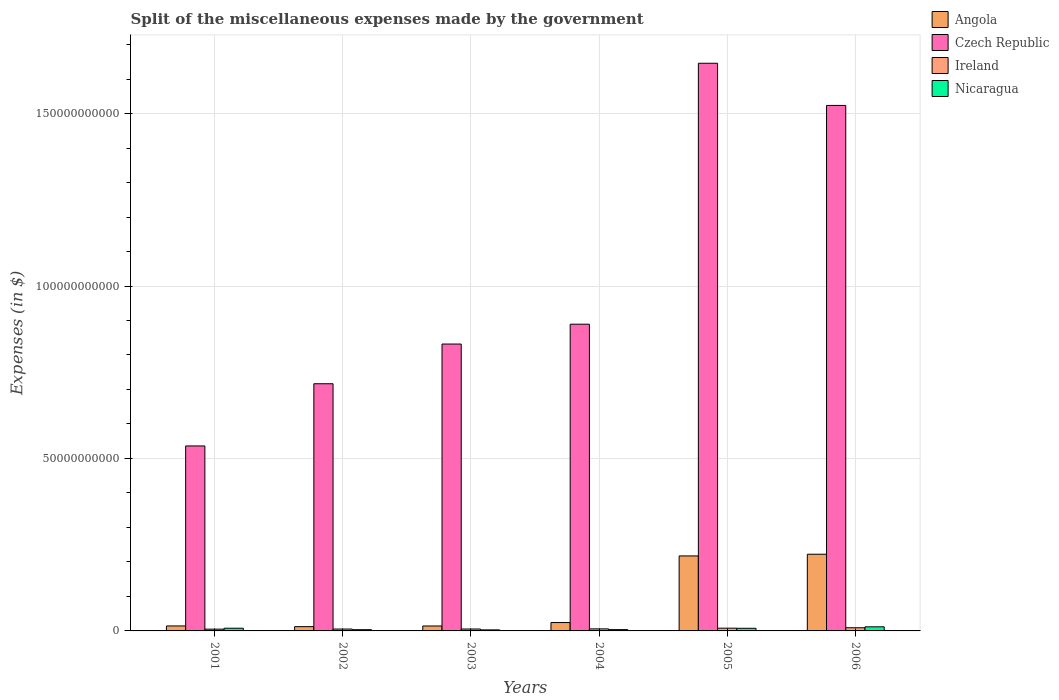How many different coloured bars are there?
Your response must be concise. 4. How many bars are there on the 3rd tick from the left?
Give a very brief answer. 4. What is the label of the 1st group of bars from the left?
Provide a short and direct response. 2001. In how many cases, is the number of bars for a given year not equal to the number of legend labels?
Give a very brief answer. 0. What is the miscellaneous expenses made by the government in Nicaragua in 2003?
Provide a short and direct response. 3.00e+08. Across all years, what is the maximum miscellaneous expenses made by the government in Angola?
Your answer should be very brief. 2.22e+1. Across all years, what is the minimum miscellaneous expenses made by the government in Ireland?
Offer a terse response. 5.16e+08. In which year was the miscellaneous expenses made by the government in Angola minimum?
Ensure brevity in your answer.  2002. What is the total miscellaneous expenses made by the government in Angola in the graph?
Provide a short and direct response. 5.05e+1. What is the difference between the miscellaneous expenses made by the government in Angola in 2003 and that in 2006?
Provide a succinct answer. -2.08e+1. What is the difference between the miscellaneous expenses made by the government in Ireland in 2005 and the miscellaneous expenses made by the government in Angola in 2004?
Your answer should be very brief. -1.63e+09. What is the average miscellaneous expenses made by the government in Angola per year?
Make the answer very short. 8.42e+09. In the year 2006, what is the difference between the miscellaneous expenses made by the government in Angola and miscellaneous expenses made by the government in Czech Republic?
Ensure brevity in your answer.  -1.30e+11. In how many years, is the miscellaneous expenses made by the government in Ireland greater than 90000000000 $?
Provide a succinct answer. 0. What is the ratio of the miscellaneous expenses made by the government in Czech Republic in 2002 to that in 2003?
Provide a succinct answer. 0.86. Is the miscellaneous expenses made by the government in Nicaragua in 2001 less than that in 2003?
Make the answer very short. No. Is the difference between the miscellaneous expenses made by the government in Angola in 2001 and 2003 greater than the difference between the miscellaneous expenses made by the government in Czech Republic in 2001 and 2003?
Your answer should be compact. Yes. What is the difference between the highest and the second highest miscellaneous expenses made by the government in Angola?
Offer a terse response. 4.93e+08. What is the difference between the highest and the lowest miscellaneous expenses made by the government in Ireland?
Your response must be concise. 4.00e+08. Is the sum of the miscellaneous expenses made by the government in Ireland in 2002 and 2004 greater than the maximum miscellaneous expenses made by the government in Nicaragua across all years?
Your answer should be very brief. No. What does the 3rd bar from the left in 2006 represents?
Provide a short and direct response. Ireland. What does the 3rd bar from the right in 2005 represents?
Make the answer very short. Czech Republic. Is it the case that in every year, the sum of the miscellaneous expenses made by the government in Nicaragua and miscellaneous expenses made by the government in Czech Republic is greater than the miscellaneous expenses made by the government in Ireland?
Provide a succinct answer. Yes. How many bars are there?
Give a very brief answer. 24. Does the graph contain any zero values?
Your answer should be very brief. No. Does the graph contain grids?
Your answer should be compact. Yes. What is the title of the graph?
Your answer should be very brief. Split of the miscellaneous expenses made by the government. What is the label or title of the Y-axis?
Your answer should be compact. Expenses (in $). What is the Expenses (in $) of Angola in 2001?
Give a very brief answer. 1.44e+09. What is the Expenses (in $) in Czech Republic in 2001?
Your answer should be very brief. 5.36e+1. What is the Expenses (in $) of Ireland in 2001?
Keep it short and to the point. 5.16e+08. What is the Expenses (in $) of Nicaragua in 2001?
Offer a terse response. 7.80e+08. What is the Expenses (in $) of Angola in 2002?
Ensure brevity in your answer.  1.24e+09. What is the Expenses (in $) of Czech Republic in 2002?
Provide a short and direct response. 7.17e+1. What is the Expenses (in $) in Ireland in 2002?
Provide a succinct answer. 5.45e+08. What is the Expenses (in $) of Nicaragua in 2002?
Offer a very short reply. 3.61e+08. What is the Expenses (in $) of Angola in 2003?
Offer a very short reply. 1.43e+09. What is the Expenses (in $) in Czech Republic in 2003?
Provide a short and direct response. 8.32e+1. What is the Expenses (in $) in Ireland in 2003?
Keep it short and to the point. 5.53e+08. What is the Expenses (in $) in Nicaragua in 2003?
Your response must be concise. 3.00e+08. What is the Expenses (in $) in Angola in 2004?
Provide a succinct answer. 2.43e+09. What is the Expenses (in $) in Czech Republic in 2004?
Provide a succinct answer. 8.89e+1. What is the Expenses (in $) of Ireland in 2004?
Provide a succinct answer. 5.91e+08. What is the Expenses (in $) of Nicaragua in 2004?
Provide a succinct answer. 3.78e+08. What is the Expenses (in $) in Angola in 2005?
Provide a short and direct response. 2.17e+1. What is the Expenses (in $) of Czech Republic in 2005?
Provide a short and direct response. 1.65e+11. What is the Expenses (in $) of Ireland in 2005?
Offer a very short reply. 7.97e+08. What is the Expenses (in $) in Nicaragua in 2005?
Your answer should be compact. 7.65e+08. What is the Expenses (in $) of Angola in 2006?
Keep it short and to the point. 2.22e+1. What is the Expenses (in $) of Czech Republic in 2006?
Make the answer very short. 1.52e+11. What is the Expenses (in $) of Ireland in 2006?
Ensure brevity in your answer.  9.16e+08. What is the Expenses (in $) in Nicaragua in 2006?
Provide a succinct answer. 1.19e+09. Across all years, what is the maximum Expenses (in $) in Angola?
Provide a short and direct response. 2.22e+1. Across all years, what is the maximum Expenses (in $) of Czech Republic?
Provide a succinct answer. 1.65e+11. Across all years, what is the maximum Expenses (in $) in Ireland?
Your answer should be compact. 9.16e+08. Across all years, what is the maximum Expenses (in $) in Nicaragua?
Keep it short and to the point. 1.19e+09. Across all years, what is the minimum Expenses (in $) of Angola?
Keep it short and to the point. 1.24e+09. Across all years, what is the minimum Expenses (in $) in Czech Republic?
Make the answer very short. 5.36e+1. Across all years, what is the minimum Expenses (in $) in Ireland?
Give a very brief answer. 5.16e+08. Across all years, what is the minimum Expenses (in $) of Nicaragua?
Your answer should be very brief. 3.00e+08. What is the total Expenses (in $) in Angola in the graph?
Offer a very short reply. 5.05e+1. What is the total Expenses (in $) of Czech Republic in the graph?
Ensure brevity in your answer.  6.14e+11. What is the total Expenses (in $) in Ireland in the graph?
Your response must be concise. 3.92e+09. What is the total Expenses (in $) of Nicaragua in the graph?
Your response must be concise. 3.77e+09. What is the difference between the Expenses (in $) in Angola in 2001 and that in 2002?
Provide a short and direct response. 2.03e+08. What is the difference between the Expenses (in $) in Czech Republic in 2001 and that in 2002?
Your answer should be very brief. -1.80e+1. What is the difference between the Expenses (in $) of Ireland in 2001 and that in 2002?
Offer a very short reply. -2.84e+07. What is the difference between the Expenses (in $) of Nicaragua in 2001 and that in 2002?
Provide a short and direct response. 4.19e+08. What is the difference between the Expenses (in $) of Angola in 2001 and that in 2003?
Provide a succinct answer. 1.12e+07. What is the difference between the Expenses (in $) in Czech Republic in 2001 and that in 2003?
Your answer should be very brief. -2.95e+1. What is the difference between the Expenses (in $) in Ireland in 2001 and that in 2003?
Give a very brief answer. -3.68e+07. What is the difference between the Expenses (in $) in Nicaragua in 2001 and that in 2003?
Provide a short and direct response. 4.80e+08. What is the difference between the Expenses (in $) of Angola in 2001 and that in 2004?
Your response must be concise. -9.87e+08. What is the difference between the Expenses (in $) of Czech Republic in 2001 and that in 2004?
Provide a succinct answer. -3.53e+1. What is the difference between the Expenses (in $) in Ireland in 2001 and that in 2004?
Provide a succinct answer. -7.49e+07. What is the difference between the Expenses (in $) in Nicaragua in 2001 and that in 2004?
Ensure brevity in your answer.  4.02e+08. What is the difference between the Expenses (in $) of Angola in 2001 and that in 2005?
Your response must be concise. -2.03e+1. What is the difference between the Expenses (in $) in Czech Republic in 2001 and that in 2005?
Your response must be concise. -1.11e+11. What is the difference between the Expenses (in $) in Ireland in 2001 and that in 2005?
Ensure brevity in your answer.  -2.81e+08. What is the difference between the Expenses (in $) in Nicaragua in 2001 and that in 2005?
Provide a short and direct response. 1.50e+07. What is the difference between the Expenses (in $) in Angola in 2001 and that in 2006?
Provide a short and direct response. -2.08e+1. What is the difference between the Expenses (in $) in Czech Republic in 2001 and that in 2006?
Ensure brevity in your answer.  -9.87e+1. What is the difference between the Expenses (in $) in Ireland in 2001 and that in 2006?
Ensure brevity in your answer.  -4.00e+08. What is the difference between the Expenses (in $) of Nicaragua in 2001 and that in 2006?
Offer a very short reply. -4.10e+08. What is the difference between the Expenses (in $) in Angola in 2002 and that in 2003?
Offer a very short reply. -1.91e+08. What is the difference between the Expenses (in $) in Czech Republic in 2002 and that in 2003?
Provide a succinct answer. -1.15e+1. What is the difference between the Expenses (in $) in Ireland in 2002 and that in 2003?
Your response must be concise. -8.35e+06. What is the difference between the Expenses (in $) of Nicaragua in 2002 and that in 2003?
Provide a succinct answer. 6.03e+07. What is the difference between the Expenses (in $) in Angola in 2002 and that in 2004?
Ensure brevity in your answer.  -1.19e+09. What is the difference between the Expenses (in $) of Czech Republic in 2002 and that in 2004?
Your answer should be compact. -1.73e+1. What is the difference between the Expenses (in $) in Ireland in 2002 and that in 2004?
Offer a terse response. -4.65e+07. What is the difference between the Expenses (in $) of Nicaragua in 2002 and that in 2004?
Keep it short and to the point. -1.71e+07. What is the difference between the Expenses (in $) in Angola in 2002 and that in 2005?
Provide a short and direct response. -2.05e+1. What is the difference between the Expenses (in $) in Czech Republic in 2002 and that in 2005?
Provide a succinct answer. -9.29e+1. What is the difference between the Expenses (in $) in Ireland in 2002 and that in 2005?
Your answer should be very brief. -2.52e+08. What is the difference between the Expenses (in $) in Nicaragua in 2002 and that in 2005?
Your answer should be compact. -4.04e+08. What is the difference between the Expenses (in $) in Angola in 2002 and that in 2006?
Provide a succinct answer. -2.10e+1. What is the difference between the Expenses (in $) in Czech Republic in 2002 and that in 2006?
Offer a terse response. -8.07e+1. What is the difference between the Expenses (in $) in Ireland in 2002 and that in 2006?
Keep it short and to the point. -3.72e+08. What is the difference between the Expenses (in $) of Nicaragua in 2002 and that in 2006?
Your response must be concise. -8.29e+08. What is the difference between the Expenses (in $) in Angola in 2003 and that in 2004?
Offer a terse response. -9.98e+08. What is the difference between the Expenses (in $) in Czech Republic in 2003 and that in 2004?
Provide a succinct answer. -5.75e+09. What is the difference between the Expenses (in $) in Ireland in 2003 and that in 2004?
Offer a very short reply. -3.82e+07. What is the difference between the Expenses (in $) in Nicaragua in 2003 and that in 2004?
Make the answer very short. -7.73e+07. What is the difference between the Expenses (in $) of Angola in 2003 and that in 2005?
Give a very brief answer. -2.03e+1. What is the difference between the Expenses (in $) in Czech Republic in 2003 and that in 2005?
Provide a succinct answer. -8.14e+1. What is the difference between the Expenses (in $) in Ireland in 2003 and that in 2005?
Give a very brief answer. -2.44e+08. What is the difference between the Expenses (in $) in Nicaragua in 2003 and that in 2005?
Keep it short and to the point. -4.65e+08. What is the difference between the Expenses (in $) of Angola in 2003 and that in 2006?
Keep it short and to the point. -2.08e+1. What is the difference between the Expenses (in $) of Czech Republic in 2003 and that in 2006?
Give a very brief answer. -6.92e+1. What is the difference between the Expenses (in $) of Ireland in 2003 and that in 2006?
Give a very brief answer. -3.63e+08. What is the difference between the Expenses (in $) of Nicaragua in 2003 and that in 2006?
Offer a very short reply. -8.89e+08. What is the difference between the Expenses (in $) of Angola in 2004 and that in 2005?
Provide a short and direct response. -1.93e+1. What is the difference between the Expenses (in $) in Czech Republic in 2004 and that in 2005?
Give a very brief answer. -7.57e+1. What is the difference between the Expenses (in $) of Ireland in 2004 and that in 2005?
Offer a very short reply. -2.06e+08. What is the difference between the Expenses (in $) of Nicaragua in 2004 and that in 2005?
Keep it short and to the point. -3.87e+08. What is the difference between the Expenses (in $) of Angola in 2004 and that in 2006?
Offer a terse response. -1.98e+1. What is the difference between the Expenses (in $) of Czech Republic in 2004 and that in 2006?
Make the answer very short. -6.34e+1. What is the difference between the Expenses (in $) of Ireland in 2004 and that in 2006?
Your answer should be very brief. -3.25e+08. What is the difference between the Expenses (in $) of Nicaragua in 2004 and that in 2006?
Provide a succinct answer. -8.12e+08. What is the difference between the Expenses (in $) in Angola in 2005 and that in 2006?
Offer a terse response. -4.93e+08. What is the difference between the Expenses (in $) of Czech Republic in 2005 and that in 2006?
Keep it short and to the point. 1.22e+1. What is the difference between the Expenses (in $) of Ireland in 2005 and that in 2006?
Offer a terse response. -1.19e+08. What is the difference between the Expenses (in $) of Nicaragua in 2005 and that in 2006?
Provide a succinct answer. -4.25e+08. What is the difference between the Expenses (in $) in Angola in 2001 and the Expenses (in $) in Czech Republic in 2002?
Your answer should be very brief. -7.02e+1. What is the difference between the Expenses (in $) of Angola in 2001 and the Expenses (in $) of Ireland in 2002?
Provide a succinct answer. 8.99e+08. What is the difference between the Expenses (in $) in Angola in 2001 and the Expenses (in $) in Nicaragua in 2002?
Keep it short and to the point. 1.08e+09. What is the difference between the Expenses (in $) of Czech Republic in 2001 and the Expenses (in $) of Ireland in 2002?
Your answer should be compact. 5.31e+1. What is the difference between the Expenses (in $) of Czech Republic in 2001 and the Expenses (in $) of Nicaragua in 2002?
Ensure brevity in your answer.  5.33e+1. What is the difference between the Expenses (in $) of Ireland in 2001 and the Expenses (in $) of Nicaragua in 2002?
Keep it short and to the point. 1.55e+08. What is the difference between the Expenses (in $) in Angola in 2001 and the Expenses (in $) in Czech Republic in 2003?
Offer a very short reply. -8.17e+1. What is the difference between the Expenses (in $) in Angola in 2001 and the Expenses (in $) in Ireland in 2003?
Make the answer very short. 8.90e+08. What is the difference between the Expenses (in $) in Angola in 2001 and the Expenses (in $) in Nicaragua in 2003?
Ensure brevity in your answer.  1.14e+09. What is the difference between the Expenses (in $) in Czech Republic in 2001 and the Expenses (in $) in Ireland in 2003?
Provide a short and direct response. 5.31e+1. What is the difference between the Expenses (in $) in Czech Republic in 2001 and the Expenses (in $) in Nicaragua in 2003?
Ensure brevity in your answer.  5.33e+1. What is the difference between the Expenses (in $) in Ireland in 2001 and the Expenses (in $) in Nicaragua in 2003?
Keep it short and to the point. 2.16e+08. What is the difference between the Expenses (in $) in Angola in 2001 and the Expenses (in $) in Czech Republic in 2004?
Ensure brevity in your answer.  -8.75e+1. What is the difference between the Expenses (in $) of Angola in 2001 and the Expenses (in $) of Ireland in 2004?
Your answer should be very brief. 8.52e+08. What is the difference between the Expenses (in $) of Angola in 2001 and the Expenses (in $) of Nicaragua in 2004?
Your answer should be very brief. 1.07e+09. What is the difference between the Expenses (in $) in Czech Republic in 2001 and the Expenses (in $) in Ireland in 2004?
Your response must be concise. 5.30e+1. What is the difference between the Expenses (in $) of Czech Republic in 2001 and the Expenses (in $) of Nicaragua in 2004?
Your answer should be compact. 5.33e+1. What is the difference between the Expenses (in $) in Ireland in 2001 and the Expenses (in $) in Nicaragua in 2004?
Make the answer very short. 1.38e+08. What is the difference between the Expenses (in $) in Angola in 2001 and the Expenses (in $) in Czech Republic in 2005?
Offer a terse response. -1.63e+11. What is the difference between the Expenses (in $) of Angola in 2001 and the Expenses (in $) of Ireland in 2005?
Give a very brief answer. 6.46e+08. What is the difference between the Expenses (in $) of Angola in 2001 and the Expenses (in $) of Nicaragua in 2005?
Offer a very short reply. 6.78e+08. What is the difference between the Expenses (in $) of Czech Republic in 2001 and the Expenses (in $) of Ireland in 2005?
Offer a terse response. 5.28e+1. What is the difference between the Expenses (in $) in Czech Republic in 2001 and the Expenses (in $) in Nicaragua in 2005?
Make the answer very short. 5.29e+1. What is the difference between the Expenses (in $) of Ireland in 2001 and the Expenses (in $) of Nicaragua in 2005?
Give a very brief answer. -2.49e+08. What is the difference between the Expenses (in $) in Angola in 2001 and the Expenses (in $) in Czech Republic in 2006?
Offer a terse response. -1.51e+11. What is the difference between the Expenses (in $) in Angola in 2001 and the Expenses (in $) in Ireland in 2006?
Ensure brevity in your answer.  5.27e+08. What is the difference between the Expenses (in $) in Angola in 2001 and the Expenses (in $) in Nicaragua in 2006?
Make the answer very short. 2.54e+08. What is the difference between the Expenses (in $) of Czech Republic in 2001 and the Expenses (in $) of Ireland in 2006?
Make the answer very short. 5.27e+1. What is the difference between the Expenses (in $) of Czech Republic in 2001 and the Expenses (in $) of Nicaragua in 2006?
Provide a short and direct response. 5.24e+1. What is the difference between the Expenses (in $) of Ireland in 2001 and the Expenses (in $) of Nicaragua in 2006?
Your answer should be compact. -6.74e+08. What is the difference between the Expenses (in $) in Angola in 2002 and the Expenses (in $) in Czech Republic in 2003?
Offer a terse response. -8.19e+1. What is the difference between the Expenses (in $) of Angola in 2002 and the Expenses (in $) of Ireland in 2003?
Make the answer very short. 6.88e+08. What is the difference between the Expenses (in $) of Angola in 2002 and the Expenses (in $) of Nicaragua in 2003?
Offer a terse response. 9.40e+08. What is the difference between the Expenses (in $) of Czech Republic in 2002 and the Expenses (in $) of Ireland in 2003?
Your answer should be very brief. 7.11e+1. What is the difference between the Expenses (in $) in Czech Republic in 2002 and the Expenses (in $) in Nicaragua in 2003?
Your answer should be compact. 7.14e+1. What is the difference between the Expenses (in $) in Ireland in 2002 and the Expenses (in $) in Nicaragua in 2003?
Provide a succinct answer. 2.44e+08. What is the difference between the Expenses (in $) in Angola in 2002 and the Expenses (in $) in Czech Republic in 2004?
Your response must be concise. -8.77e+1. What is the difference between the Expenses (in $) in Angola in 2002 and the Expenses (in $) in Ireland in 2004?
Offer a terse response. 6.50e+08. What is the difference between the Expenses (in $) of Angola in 2002 and the Expenses (in $) of Nicaragua in 2004?
Your response must be concise. 8.63e+08. What is the difference between the Expenses (in $) in Czech Republic in 2002 and the Expenses (in $) in Ireland in 2004?
Your answer should be compact. 7.11e+1. What is the difference between the Expenses (in $) in Czech Republic in 2002 and the Expenses (in $) in Nicaragua in 2004?
Provide a short and direct response. 7.13e+1. What is the difference between the Expenses (in $) of Ireland in 2002 and the Expenses (in $) of Nicaragua in 2004?
Your answer should be very brief. 1.67e+08. What is the difference between the Expenses (in $) in Angola in 2002 and the Expenses (in $) in Czech Republic in 2005?
Offer a terse response. -1.63e+11. What is the difference between the Expenses (in $) in Angola in 2002 and the Expenses (in $) in Ireland in 2005?
Make the answer very short. 4.44e+08. What is the difference between the Expenses (in $) in Angola in 2002 and the Expenses (in $) in Nicaragua in 2005?
Your answer should be very brief. 4.76e+08. What is the difference between the Expenses (in $) of Czech Republic in 2002 and the Expenses (in $) of Ireland in 2005?
Provide a short and direct response. 7.09e+1. What is the difference between the Expenses (in $) of Czech Republic in 2002 and the Expenses (in $) of Nicaragua in 2005?
Your response must be concise. 7.09e+1. What is the difference between the Expenses (in $) in Ireland in 2002 and the Expenses (in $) in Nicaragua in 2005?
Make the answer very short. -2.20e+08. What is the difference between the Expenses (in $) of Angola in 2002 and the Expenses (in $) of Czech Republic in 2006?
Ensure brevity in your answer.  -1.51e+11. What is the difference between the Expenses (in $) of Angola in 2002 and the Expenses (in $) of Ireland in 2006?
Make the answer very short. 3.25e+08. What is the difference between the Expenses (in $) of Angola in 2002 and the Expenses (in $) of Nicaragua in 2006?
Your answer should be very brief. 5.10e+07. What is the difference between the Expenses (in $) of Czech Republic in 2002 and the Expenses (in $) of Ireland in 2006?
Ensure brevity in your answer.  7.07e+1. What is the difference between the Expenses (in $) in Czech Republic in 2002 and the Expenses (in $) in Nicaragua in 2006?
Give a very brief answer. 7.05e+1. What is the difference between the Expenses (in $) in Ireland in 2002 and the Expenses (in $) in Nicaragua in 2006?
Provide a short and direct response. -6.45e+08. What is the difference between the Expenses (in $) in Angola in 2003 and the Expenses (in $) in Czech Republic in 2004?
Offer a very short reply. -8.75e+1. What is the difference between the Expenses (in $) of Angola in 2003 and the Expenses (in $) of Ireland in 2004?
Your answer should be compact. 8.41e+08. What is the difference between the Expenses (in $) of Angola in 2003 and the Expenses (in $) of Nicaragua in 2004?
Your response must be concise. 1.05e+09. What is the difference between the Expenses (in $) of Czech Republic in 2003 and the Expenses (in $) of Ireland in 2004?
Your answer should be compact. 8.26e+1. What is the difference between the Expenses (in $) of Czech Republic in 2003 and the Expenses (in $) of Nicaragua in 2004?
Your answer should be compact. 8.28e+1. What is the difference between the Expenses (in $) in Ireland in 2003 and the Expenses (in $) in Nicaragua in 2004?
Make the answer very short. 1.75e+08. What is the difference between the Expenses (in $) of Angola in 2003 and the Expenses (in $) of Czech Republic in 2005?
Provide a succinct answer. -1.63e+11. What is the difference between the Expenses (in $) of Angola in 2003 and the Expenses (in $) of Ireland in 2005?
Your answer should be compact. 6.35e+08. What is the difference between the Expenses (in $) of Angola in 2003 and the Expenses (in $) of Nicaragua in 2005?
Keep it short and to the point. 6.67e+08. What is the difference between the Expenses (in $) of Czech Republic in 2003 and the Expenses (in $) of Ireland in 2005?
Provide a short and direct response. 8.24e+1. What is the difference between the Expenses (in $) of Czech Republic in 2003 and the Expenses (in $) of Nicaragua in 2005?
Give a very brief answer. 8.24e+1. What is the difference between the Expenses (in $) in Ireland in 2003 and the Expenses (in $) in Nicaragua in 2005?
Offer a very short reply. -2.12e+08. What is the difference between the Expenses (in $) in Angola in 2003 and the Expenses (in $) in Czech Republic in 2006?
Make the answer very short. -1.51e+11. What is the difference between the Expenses (in $) of Angola in 2003 and the Expenses (in $) of Ireland in 2006?
Your answer should be compact. 5.16e+08. What is the difference between the Expenses (in $) in Angola in 2003 and the Expenses (in $) in Nicaragua in 2006?
Provide a short and direct response. 2.42e+08. What is the difference between the Expenses (in $) of Czech Republic in 2003 and the Expenses (in $) of Ireland in 2006?
Make the answer very short. 8.23e+1. What is the difference between the Expenses (in $) in Czech Republic in 2003 and the Expenses (in $) in Nicaragua in 2006?
Your answer should be compact. 8.20e+1. What is the difference between the Expenses (in $) of Ireland in 2003 and the Expenses (in $) of Nicaragua in 2006?
Give a very brief answer. -6.37e+08. What is the difference between the Expenses (in $) of Angola in 2004 and the Expenses (in $) of Czech Republic in 2005?
Your response must be concise. -1.62e+11. What is the difference between the Expenses (in $) of Angola in 2004 and the Expenses (in $) of Ireland in 2005?
Offer a terse response. 1.63e+09. What is the difference between the Expenses (in $) in Angola in 2004 and the Expenses (in $) in Nicaragua in 2005?
Provide a short and direct response. 1.67e+09. What is the difference between the Expenses (in $) in Czech Republic in 2004 and the Expenses (in $) in Ireland in 2005?
Offer a very short reply. 8.81e+1. What is the difference between the Expenses (in $) in Czech Republic in 2004 and the Expenses (in $) in Nicaragua in 2005?
Offer a terse response. 8.82e+1. What is the difference between the Expenses (in $) of Ireland in 2004 and the Expenses (in $) of Nicaragua in 2005?
Give a very brief answer. -1.74e+08. What is the difference between the Expenses (in $) in Angola in 2004 and the Expenses (in $) in Czech Republic in 2006?
Make the answer very short. -1.50e+11. What is the difference between the Expenses (in $) of Angola in 2004 and the Expenses (in $) of Ireland in 2006?
Offer a very short reply. 1.51e+09. What is the difference between the Expenses (in $) in Angola in 2004 and the Expenses (in $) in Nicaragua in 2006?
Ensure brevity in your answer.  1.24e+09. What is the difference between the Expenses (in $) of Czech Republic in 2004 and the Expenses (in $) of Ireland in 2006?
Ensure brevity in your answer.  8.80e+1. What is the difference between the Expenses (in $) in Czech Republic in 2004 and the Expenses (in $) in Nicaragua in 2006?
Provide a succinct answer. 8.77e+1. What is the difference between the Expenses (in $) of Ireland in 2004 and the Expenses (in $) of Nicaragua in 2006?
Give a very brief answer. -5.99e+08. What is the difference between the Expenses (in $) in Angola in 2005 and the Expenses (in $) in Czech Republic in 2006?
Offer a very short reply. -1.31e+11. What is the difference between the Expenses (in $) in Angola in 2005 and the Expenses (in $) in Ireland in 2006?
Offer a very short reply. 2.08e+1. What is the difference between the Expenses (in $) of Angola in 2005 and the Expenses (in $) of Nicaragua in 2006?
Ensure brevity in your answer.  2.06e+1. What is the difference between the Expenses (in $) in Czech Republic in 2005 and the Expenses (in $) in Ireland in 2006?
Provide a succinct answer. 1.64e+11. What is the difference between the Expenses (in $) of Czech Republic in 2005 and the Expenses (in $) of Nicaragua in 2006?
Offer a very short reply. 1.63e+11. What is the difference between the Expenses (in $) in Ireland in 2005 and the Expenses (in $) in Nicaragua in 2006?
Your answer should be compact. -3.93e+08. What is the average Expenses (in $) of Angola per year?
Offer a very short reply. 8.42e+09. What is the average Expenses (in $) in Czech Republic per year?
Make the answer very short. 1.02e+11. What is the average Expenses (in $) in Ireland per year?
Offer a terse response. 6.53e+08. What is the average Expenses (in $) of Nicaragua per year?
Give a very brief answer. 6.29e+08. In the year 2001, what is the difference between the Expenses (in $) in Angola and Expenses (in $) in Czech Republic?
Offer a terse response. -5.22e+1. In the year 2001, what is the difference between the Expenses (in $) of Angola and Expenses (in $) of Ireland?
Your answer should be very brief. 9.27e+08. In the year 2001, what is the difference between the Expenses (in $) in Angola and Expenses (in $) in Nicaragua?
Your response must be concise. 6.63e+08. In the year 2001, what is the difference between the Expenses (in $) in Czech Republic and Expenses (in $) in Ireland?
Make the answer very short. 5.31e+1. In the year 2001, what is the difference between the Expenses (in $) in Czech Republic and Expenses (in $) in Nicaragua?
Offer a very short reply. 5.28e+1. In the year 2001, what is the difference between the Expenses (in $) in Ireland and Expenses (in $) in Nicaragua?
Your response must be concise. -2.64e+08. In the year 2002, what is the difference between the Expenses (in $) of Angola and Expenses (in $) of Czech Republic?
Your response must be concise. -7.04e+1. In the year 2002, what is the difference between the Expenses (in $) of Angola and Expenses (in $) of Ireland?
Provide a succinct answer. 6.96e+08. In the year 2002, what is the difference between the Expenses (in $) in Angola and Expenses (in $) in Nicaragua?
Your answer should be very brief. 8.80e+08. In the year 2002, what is the difference between the Expenses (in $) of Czech Republic and Expenses (in $) of Ireland?
Offer a terse response. 7.11e+1. In the year 2002, what is the difference between the Expenses (in $) of Czech Republic and Expenses (in $) of Nicaragua?
Your answer should be very brief. 7.13e+1. In the year 2002, what is the difference between the Expenses (in $) of Ireland and Expenses (in $) of Nicaragua?
Give a very brief answer. 1.84e+08. In the year 2003, what is the difference between the Expenses (in $) of Angola and Expenses (in $) of Czech Republic?
Make the answer very short. -8.17e+1. In the year 2003, what is the difference between the Expenses (in $) of Angola and Expenses (in $) of Ireland?
Give a very brief answer. 8.79e+08. In the year 2003, what is the difference between the Expenses (in $) in Angola and Expenses (in $) in Nicaragua?
Provide a succinct answer. 1.13e+09. In the year 2003, what is the difference between the Expenses (in $) of Czech Republic and Expenses (in $) of Ireland?
Offer a very short reply. 8.26e+1. In the year 2003, what is the difference between the Expenses (in $) in Czech Republic and Expenses (in $) in Nicaragua?
Provide a succinct answer. 8.29e+1. In the year 2003, what is the difference between the Expenses (in $) of Ireland and Expenses (in $) of Nicaragua?
Provide a short and direct response. 2.52e+08. In the year 2004, what is the difference between the Expenses (in $) of Angola and Expenses (in $) of Czech Republic?
Give a very brief answer. -8.65e+1. In the year 2004, what is the difference between the Expenses (in $) in Angola and Expenses (in $) in Ireland?
Provide a succinct answer. 1.84e+09. In the year 2004, what is the difference between the Expenses (in $) of Angola and Expenses (in $) of Nicaragua?
Offer a very short reply. 2.05e+09. In the year 2004, what is the difference between the Expenses (in $) in Czech Republic and Expenses (in $) in Ireland?
Give a very brief answer. 8.83e+1. In the year 2004, what is the difference between the Expenses (in $) of Czech Republic and Expenses (in $) of Nicaragua?
Provide a succinct answer. 8.86e+1. In the year 2004, what is the difference between the Expenses (in $) in Ireland and Expenses (in $) in Nicaragua?
Ensure brevity in your answer.  2.13e+08. In the year 2005, what is the difference between the Expenses (in $) of Angola and Expenses (in $) of Czech Republic?
Make the answer very short. -1.43e+11. In the year 2005, what is the difference between the Expenses (in $) in Angola and Expenses (in $) in Ireland?
Your response must be concise. 2.09e+1. In the year 2005, what is the difference between the Expenses (in $) of Angola and Expenses (in $) of Nicaragua?
Offer a very short reply. 2.10e+1. In the year 2005, what is the difference between the Expenses (in $) in Czech Republic and Expenses (in $) in Ireland?
Provide a short and direct response. 1.64e+11. In the year 2005, what is the difference between the Expenses (in $) of Czech Republic and Expenses (in $) of Nicaragua?
Keep it short and to the point. 1.64e+11. In the year 2005, what is the difference between the Expenses (in $) in Ireland and Expenses (in $) in Nicaragua?
Provide a short and direct response. 3.20e+07. In the year 2006, what is the difference between the Expenses (in $) in Angola and Expenses (in $) in Czech Republic?
Ensure brevity in your answer.  -1.30e+11. In the year 2006, what is the difference between the Expenses (in $) of Angola and Expenses (in $) of Ireland?
Ensure brevity in your answer.  2.13e+1. In the year 2006, what is the difference between the Expenses (in $) in Angola and Expenses (in $) in Nicaragua?
Offer a very short reply. 2.10e+1. In the year 2006, what is the difference between the Expenses (in $) in Czech Republic and Expenses (in $) in Ireland?
Your answer should be very brief. 1.51e+11. In the year 2006, what is the difference between the Expenses (in $) of Czech Republic and Expenses (in $) of Nicaragua?
Ensure brevity in your answer.  1.51e+11. In the year 2006, what is the difference between the Expenses (in $) in Ireland and Expenses (in $) in Nicaragua?
Provide a succinct answer. -2.74e+08. What is the ratio of the Expenses (in $) in Angola in 2001 to that in 2002?
Your answer should be compact. 1.16. What is the ratio of the Expenses (in $) in Czech Republic in 2001 to that in 2002?
Provide a succinct answer. 0.75. What is the ratio of the Expenses (in $) of Ireland in 2001 to that in 2002?
Provide a short and direct response. 0.95. What is the ratio of the Expenses (in $) in Nicaragua in 2001 to that in 2002?
Provide a succinct answer. 2.16. What is the ratio of the Expenses (in $) in Angola in 2001 to that in 2003?
Provide a succinct answer. 1.01. What is the ratio of the Expenses (in $) of Czech Republic in 2001 to that in 2003?
Provide a short and direct response. 0.64. What is the ratio of the Expenses (in $) of Ireland in 2001 to that in 2003?
Give a very brief answer. 0.93. What is the ratio of the Expenses (in $) of Nicaragua in 2001 to that in 2003?
Offer a very short reply. 2.6. What is the ratio of the Expenses (in $) in Angola in 2001 to that in 2004?
Keep it short and to the point. 0.59. What is the ratio of the Expenses (in $) in Czech Republic in 2001 to that in 2004?
Provide a succinct answer. 0.6. What is the ratio of the Expenses (in $) in Ireland in 2001 to that in 2004?
Offer a terse response. 0.87. What is the ratio of the Expenses (in $) in Nicaragua in 2001 to that in 2004?
Provide a short and direct response. 2.06. What is the ratio of the Expenses (in $) in Angola in 2001 to that in 2005?
Offer a terse response. 0.07. What is the ratio of the Expenses (in $) of Czech Republic in 2001 to that in 2005?
Provide a succinct answer. 0.33. What is the ratio of the Expenses (in $) of Ireland in 2001 to that in 2005?
Make the answer very short. 0.65. What is the ratio of the Expenses (in $) of Nicaragua in 2001 to that in 2005?
Your response must be concise. 1.02. What is the ratio of the Expenses (in $) in Angola in 2001 to that in 2006?
Offer a terse response. 0.06. What is the ratio of the Expenses (in $) of Czech Republic in 2001 to that in 2006?
Keep it short and to the point. 0.35. What is the ratio of the Expenses (in $) in Ireland in 2001 to that in 2006?
Your response must be concise. 0.56. What is the ratio of the Expenses (in $) in Nicaragua in 2001 to that in 2006?
Provide a short and direct response. 0.66. What is the ratio of the Expenses (in $) of Angola in 2002 to that in 2003?
Provide a short and direct response. 0.87. What is the ratio of the Expenses (in $) of Czech Republic in 2002 to that in 2003?
Offer a terse response. 0.86. What is the ratio of the Expenses (in $) of Ireland in 2002 to that in 2003?
Provide a succinct answer. 0.98. What is the ratio of the Expenses (in $) of Nicaragua in 2002 to that in 2003?
Ensure brevity in your answer.  1.2. What is the ratio of the Expenses (in $) of Angola in 2002 to that in 2004?
Give a very brief answer. 0.51. What is the ratio of the Expenses (in $) of Czech Republic in 2002 to that in 2004?
Ensure brevity in your answer.  0.81. What is the ratio of the Expenses (in $) in Ireland in 2002 to that in 2004?
Offer a very short reply. 0.92. What is the ratio of the Expenses (in $) in Nicaragua in 2002 to that in 2004?
Provide a short and direct response. 0.95. What is the ratio of the Expenses (in $) in Angola in 2002 to that in 2005?
Keep it short and to the point. 0.06. What is the ratio of the Expenses (in $) in Czech Republic in 2002 to that in 2005?
Your answer should be compact. 0.44. What is the ratio of the Expenses (in $) in Ireland in 2002 to that in 2005?
Keep it short and to the point. 0.68. What is the ratio of the Expenses (in $) in Nicaragua in 2002 to that in 2005?
Give a very brief answer. 0.47. What is the ratio of the Expenses (in $) of Angola in 2002 to that in 2006?
Your response must be concise. 0.06. What is the ratio of the Expenses (in $) of Czech Republic in 2002 to that in 2006?
Your answer should be very brief. 0.47. What is the ratio of the Expenses (in $) in Ireland in 2002 to that in 2006?
Provide a short and direct response. 0.59. What is the ratio of the Expenses (in $) in Nicaragua in 2002 to that in 2006?
Your answer should be very brief. 0.3. What is the ratio of the Expenses (in $) of Angola in 2003 to that in 2004?
Give a very brief answer. 0.59. What is the ratio of the Expenses (in $) of Czech Republic in 2003 to that in 2004?
Provide a short and direct response. 0.94. What is the ratio of the Expenses (in $) in Ireland in 2003 to that in 2004?
Provide a succinct answer. 0.94. What is the ratio of the Expenses (in $) in Nicaragua in 2003 to that in 2004?
Provide a succinct answer. 0.8. What is the ratio of the Expenses (in $) in Angola in 2003 to that in 2005?
Provide a short and direct response. 0.07. What is the ratio of the Expenses (in $) of Czech Republic in 2003 to that in 2005?
Provide a short and direct response. 0.51. What is the ratio of the Expenses (in $) in Ireland in 2003 to that in 2005?
Give a very brief answer. 0.69. What is the ratio of the Expenses (in $) in Nicaragua in 2003 to that in 2005?
Offer a terse response. 0.39. What is the ratio of the Expenses (in $) of Angola in 2003 to that in 2006?
Offer a terse response. 0.06. What is the ratio of the Expenses (in $) in Czech Republic in 2003 to that in 2006?
Keep it short and to the point. 0.55. What is the ratio of the Expenses (in $) in Ireland in 2003 to that in 2006?
Give a very brief answer. 0.6. What is the ratio of the Expenses (in $) in Nicaragua in 2003 to that in 2006?
Provide a succinct answer. 0.25. What is the ratio of the Expenses (in $) in Angola in 2004 to that in 2005?
Your response must be concise. 0.11. What is the ratio of the Expenses (in $) of Czech Republic in 2004 to that in 2005?
Your response must be concise. 0.54. What is the ratio of the Expenses (in $) in Ireland in 2004 to that in 2005?
Your answer should be very brief. 0.74. What is the ratio of the Expenses (in $) of Nicaragua in 2004 to that in 2005?
Your answer should be compact. 0.49. What is the ratio of the Expenses (in $) in Angola in 2004 to that in 2006?
Provide a succinct answer. 0.11. What is the ratio of the Expenses (in $) of Czech Republic in 2004 to that in 2006?
Make the answer very short. 0.58. What is the ratio of the Expenses (in $) of Ireland in 2004 to that in 2006?
Provide a short and direct response. 0.65. What is the ratio of the Expenses (in $) of Nicaragua in 2004 to that in 2006?
Your answer should be very brief. 0.32. What is the ratio of the Expenses (in $) of Angola in 2005 to that in 2006?
Offer a terse response. 0.98. What is the ratio of the Expenses (in $) of Czech Republic in 2005 to that in 2006?
Offer a very short reply. 1.08. What is the ratio of the Expenses (in $) of Ireland in 2005 to that in 2006?
Your response must be concise. 0.87. What is the ratio of the Expenses (in $) of Nicaragua in 2005 to that in 2006?
Your answer should be very brief. 0.64. What is the difference between the highest and the second highest Expenses (in $) of Angola?
Provide a succinct answer. 4.93e+08. What is the difference between the highest and the second highest Expenses (in $) in Czech Republic?
Your answer should be compact. 1.22e+1. What is the difference between the highest and the second highest Expenses (in $) of Ireland?
Make the answer very short. 1.19e+08. What is the difference between the highest and the second highest Expenses (in $) in Nicaragua?
Give a very brief answer. 4.10e+08. What is the difference between the highest and the lowest Expenses (in $) of Angola?
Your answer should be compact. 2.10e+1. What is the difference between the highest and the lowest Expenses (in $) in Czech Republic?
Offer a terse response. 1.11e+11. What is the difference between the highest and the lowest Expenses (in $) of Ireland?
Keep it short and to the point. 4.00e+08. What is the difference between the highest and the lowest Expenses (in $) in Nicaragua?
Offer a very short reply. 8.89e+08. 